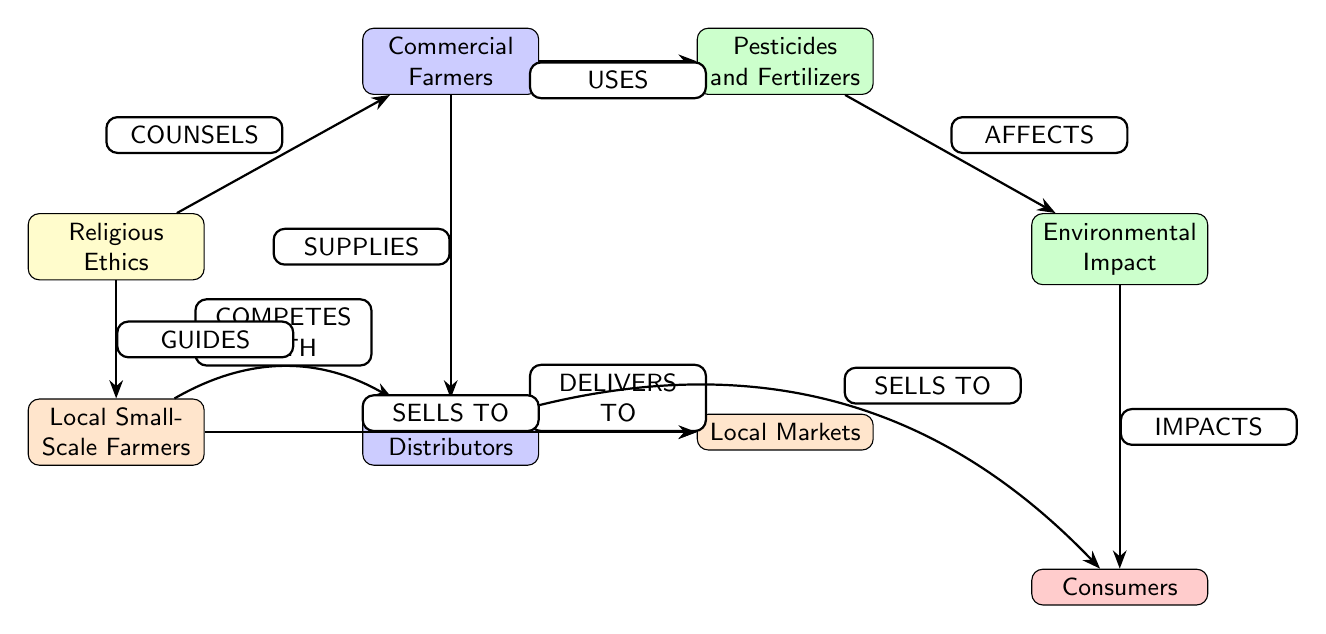What guides local small-scale farmers? The "Religious Ethics" node is connected to the "Local Small-Scale Farmers" node with the label "GUIDES," indicating that it plays a guiding role in their practices.
Answer: Religious Ethics What affects the environmental impact? The "Pesticides and Fertilizers" node is connected to the "Environmental Impact" node with the label "AFFECTS," which means the use of these substances has a direct effect on the environment.
Answer: Pesticides and Fertilizers How many nodes are in the diagram? There are a total of 7 nodes represented in the diagram, including categories for religious, commercial, environmental, local, and consumer aspects.
Answer: 7 Who supplies the supply chain distributors? The "Commercial Farmers" node is linked to the "Supply Chain Distributors" node with the label "SUPPLIES," meaning they are the source for these distributors.
Answer: Commercial Farmers What is the relationship between local small-scale farmers and local markets? The "Local Small-Scale Farmers" node is connected to the "Local Markets" node with the label "SELLS TO," indicating that these farmers sell their produce directly to these markets.
Answer: Sells To What impacts consumers according to the diagram? The "Environmental Impact" node is connected to the "Consumers" node with the label "IMPACTS," suggesting that the environmental effects influence consumer choices or experiences.
Answer: Impacts What do commercial farmers and local small-scale farmers do regarding supply chain distributors? The "Commercial Farmers" compete with the "Local Small-Scale Farmers" for the "Supply Chain Distributors," as indicated by the "COMPETES WITH" connection showing an interaction between their supply strategies.
Answer: Competes With What do local markets sell to? The "Local Markets" node is linked to the "Consumers" node with the label "SELLS TO," indicating that local markets are a point-of-sale for consumers.
Answer: Consumers Who counsels commercial farmers? The "Religious Ethics" node has a connection labeled "COUNSELS" leading to the "Commercial Farmers" node, indicating that religious beliefs or authorities provide guidance to these farmers.
Answer: Religious Ethics 